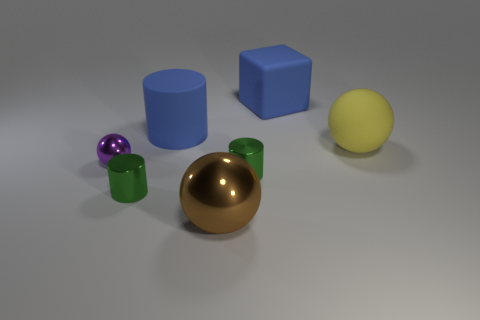There is a thing that is the same color as the matte cylinder; what is it made of?
Offer a terse response. Rubber. What is the color of the cylinder that is to the right of the sphere that is in front of the tiny purple metallic ball?
Your answer should be very brief. Green. Is there a big ball that has the same color as the tiny sphere?
Your response must be concise. No. What is the shape of the brown object that is the same size as the matte ball?
Keep it short and to the point. Sphere. There is a large object in front of the purple shiny ball; how many small green cylinders are right of it?
Provide a short and direct response. 1. Does the small metallic ball have the same color as the rubber cylinder?
Give a very brief answer. No. What number of other things are the same material as the small purple thing?
Provide a succinct answer. 3. There is a small green thing to the left of the large ball in front of the small purple ball; what is its shape?
Offer a very short reply. Cylinder. There is a cylinder that is behind the rubber ball; how big is it?
Offer a terse response. Large. Do the blue cylinder and the yellow ball have the same material?
Your response must be concise. Yes. 